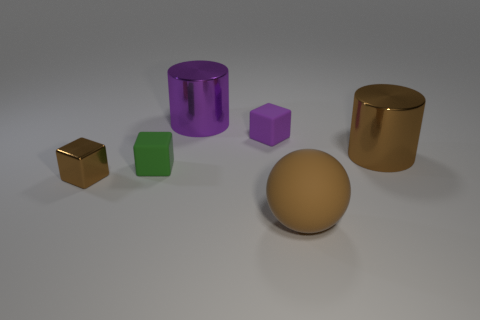There is a metallic cylinder that is the same color as the ball; what is its size?
Offer a terse response. Large. There is a brown metal object that is right of the brown metal cube; is its shape the same as the large object to the left of the small purple block?
Make the answer very short. Yes. There is a brown cylinder that is the same size as the purple metallic object; what material is it?
Provide a succinct answer. Metal. What is the color of the rubber thing that is in front of the brown cylinder and behind the big brown rubber ball?
Provide a succinct answer. Green. What number of other objects are there of the same color as the small shiny block?
Your answer should be compact. 2. What material is the large cylinder that is in front of the object that is behind the tiny matte thing on the right side of the green cube?
Your answer should be very brief. Metal. How many blocks are either tiny blue metallic things or tiny green objects?
Your answer should be very brief. 1. Is there anything else that has the same size as the shiny cube?
Give a very brief answer. Yes. How many metal cubes are to the right of the cylinder behind the cylinder right of the brown matte ball?
Ensure brevity in your answer.  0. Do the tiny green matte thing and the purple matte thing have the same shape?
Give a very brief answer. Yes. 